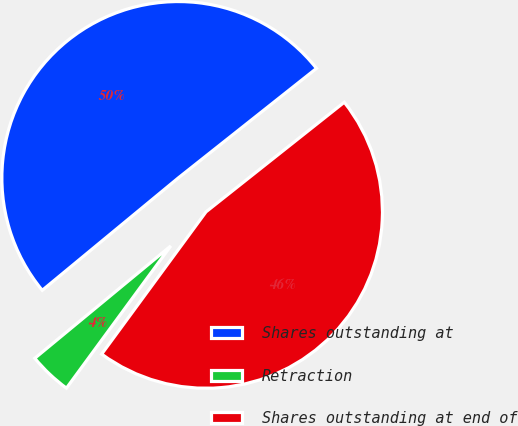<chart> <loc_0><loc_0><loc_500><loc_500><pie_chart><fcel>Shares outstanding at<fcel>Retraction<fcel>Shares outstanding at end of<nl><fcel>50.32%<fcel>3.94%<fcel>45.74%<nl></chart> 